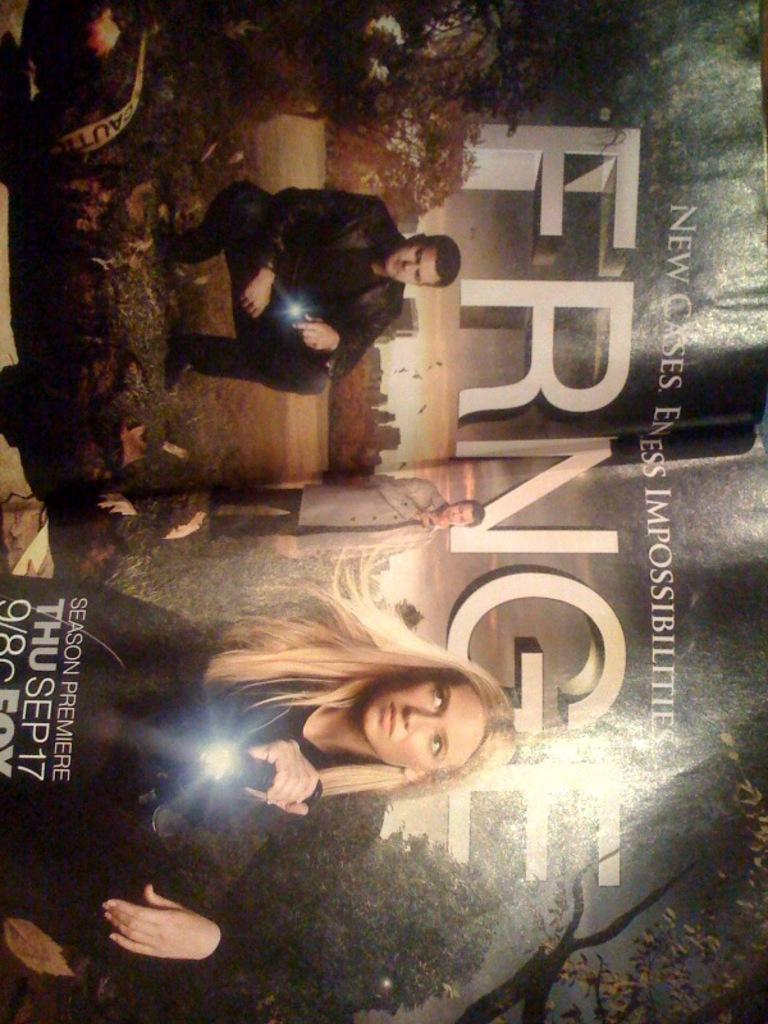<image>
Share a concise interpretation of the image provided. a magazine ad for Fringe Season Premier Thu Sep 17 